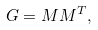Convert formula to latex. <formula><loc_0><loc_0><loc_500><loc_500>G = M M ^ { T } ,</formula> 